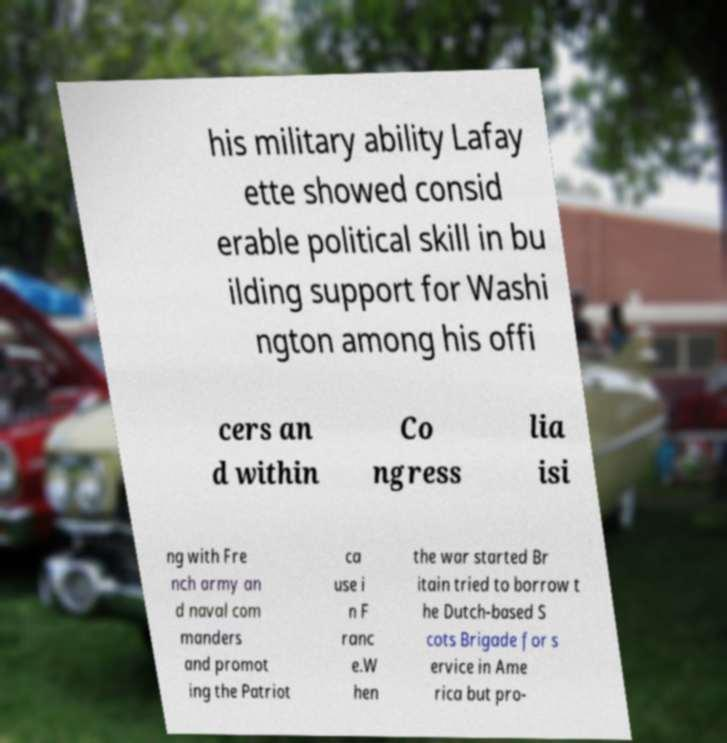I need the written content from this picture converted into text. Can you do that? his military ability Lafay ette showed consid erable political skill in bu ilding support for Washi ngton among his offi cers an d within Co ngress lia isi ng with Fre nch army an d naval com manders and promot ing the Patriot ca use i n F ranc e.W hen the war started Br itain tried to borrow t he Dutch-based S cots Brigade for s ervice in Ame rica but pro- 